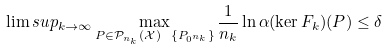Convert formula to latex. <formula><loc_0><loc_0><loc_500><loc_500>\lim s u p _ { k \to \infty } \max _ { P \in \mathcal { P } _ { n _ { k } } ( \mathcal { X } ) \ \{ P _ { 0 ^ { n _ { k } } } \} } \frac { 1 } { n _ { k } } \ln \alpha ( \ker F _ { k } ) ( P ) \leq \delta</formula> 